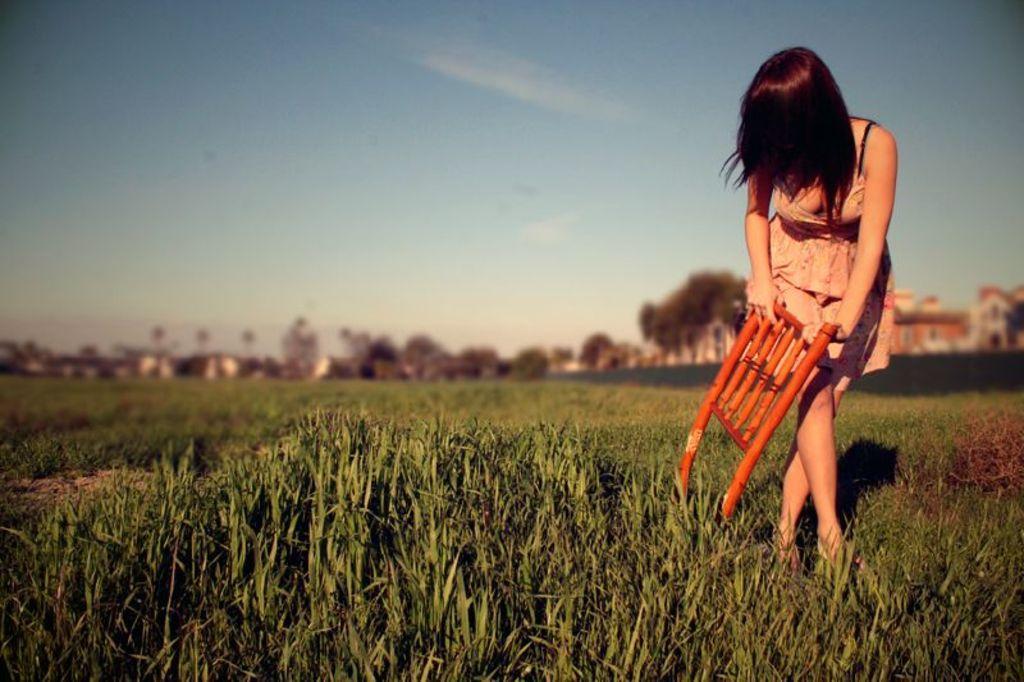Please provide a concise description of this image. In this picture we can see a woman holding an object in her hand. In the background, we can see a group of trees, buildings and the sky. 